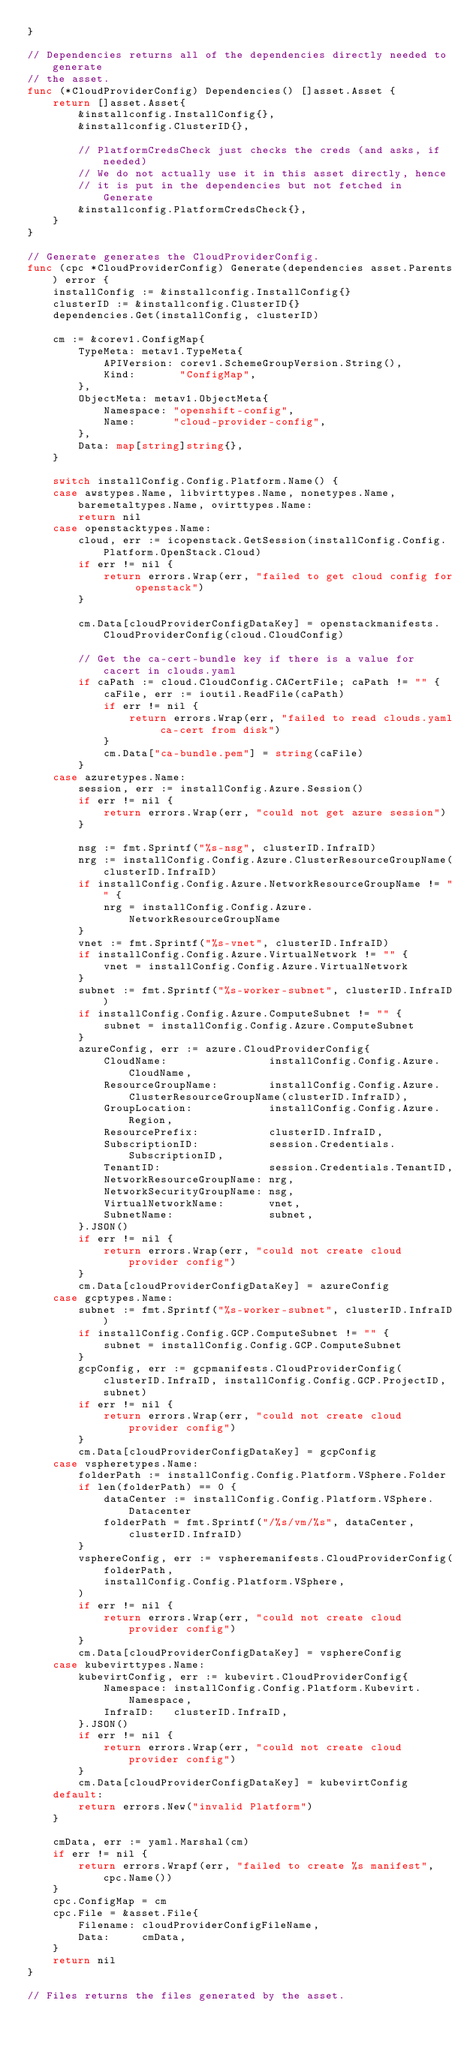<code> <loc_0><loc_0><loc_500><loc_500><_Go_>}

// Dependencies returns all of the dependencies directly needed to generate
// the asset.
func (*CloudProviderConfig) Dependencies() []asset.Asset {
	return []asset.Asset{
		&installconfig.InstallConfig{},
		&installconfig.ClusterID{},

		// PlatformCredsCheck just checks the creds (and asks, if needed)
		// We do not actually use it in this asset directly, hence
		// it is put in the dependencies but not fetched in Generate
		&installconfig.PlatformCredsCheck{},
	}
}

// Generate generates the CloudProviderConfig.
func (cpc *CloudProviderConfig) Generate(dependencies asset.Parents) error {
	installConfig := &installconfig.InstallConfig{}
	clusterID := &installconfig.ClusterID{}
	dependencies.Get(installConfig, clusterID)

	cm := &corev1.ConfigMap{
		TypeMeta: metav1.TypeMeta{
			APIVersion: corev1.SchemeGroupVersion.String(),
			Kind:       "ConfigMap",
		},
		ObjectMeta: metav1.ObjectMeta{
			Namespace: "openshift-config",
			Name:      "cloud-provider-config",
		},
		Data: map[string]string{},
	}

	switch installConfig.Config.Platform.Name() {
	case awstypes.Name, libvirttypes.Name, nonetypes.Name, baremetaltypes.Name, ovirttypes.Name:
		return nil
	case openstacktypes.Name:
		cloud, err := icopenstack.GetSession(installConfig.Config.Platform.OpenStack.Cloud)
		if err != nil {
			return errors.Wrap(err, "failed to get cloud config for openstack")
		}

		cm.Data[cloudProviderConfigDataKey] = openstackmanifests.CloudProviderConfig(cloud.CloudConfig)

		// Get the ca-cert-bundle key if there is a value for cacert in clouds.yaml
		if caPath := cloud.CloudConfig.CACertFile; caPath != "" {
			caFile, err := ioutil.ReadFile(caPath)
			if err != nil {
				return errors.Wrap(err, "failed to read clouds.yaml ca-cert from disk")
			}
			cm.Data["ca-bundle.pem"] = string(caFile)
		}
	case azuretypes.Name:
		session, err := installConfig.Azure.Session()
		if err != nil {
			return errors.Wrap(err, "could not get azure session")
		}

		nsg := fmt.Sprintf("%s-nsg", clusterID.InfraID)
		nrg := installConfig.Config.Azure.ClusterResourceGroupName(clusterID.InfraID)
		if installConfig.Config.Azure.NetworkResourceGroupName != "" {
			nrg = installConfig.Config.Azure.NetworkResourceGroupName
		}
		vnet := fmt.Sprintf("%s-vnet", clusterID.InfraID)
		if installConfig.Config.Azure.VirtualNetwork != "" {
			vnet = installConfig.Config.Azure.VirtualNetwork
		}
		subnet := fmt.Sprintf("%s-worker-subnet", clusterID.InfraID)
		if installConfig.Config.Azure.ComputeSubnet != "" {
			subnet = installConfig.Config.Azure.ComputeSubnet
		}
		azureConfig, err := azure.CloudProviderConfig{
			CloudName:                installConfig.Config.Azure.CloudName,
			ResourceGroupName:        installConfig.Config.Azure.ClusterResourceGroupName(clusterID.InfraID),
			GroupLocation:            installConfig.Config.Azure.Region,
			ResourcePrefix:           clusterID.InfraID,
			SubscriptionID:           session.Credentials.SubscriptionID,
			TenantID:                 session.Credentials.TenantID,
			NetworkResourceGroupName: nrg,
			NetworkSecurityGroupName: nsg,
			VirtualNetworkName:       vnet,
			SubnetName:               subnet,
		}.JSON()
		if err != nil {
			return errors.Wrap(err, "could not create cloud provider config")
		}
		cm.Data[cloudProviderConfigDataKey] = azureConfig
	case gcptypes.Name:
		subnet := fmt.Sprintf("%s-worker-subnet", clusterID.InfraID)
		if installConfig.Config.GCP.ComputeSubnet != "" {
			subnet = installConfig.Config.GCP.ComputeSubnet
		}
		gcpConfig, err := gcpmanifests.CloudProviderConfig(clusterID.InfraID, installConfig.Config.GCP.ProjectID, subnet)
		if err != nil {
			return errors.Wrap(err, "could not create cloud provider config")
		}
		cm.Data[cloudProviderConfigDataKey] = gcpConfig
	case vspheretypes.Name:
		folderPath := installConfig.Config.Platform.VSphere.Folder
		if len(folderPath) == 0 {
			dataCenter := installConfig.Config.Platform.VSphere.Datacenter
			folderPath = fmt.Sprintf("/%s/vm/%s", dataCenter, clusterID.InfraID)
		}
		vsphereConfig, err := vspheremanifests.CloudProviderConfig(
			folderPath,
			installConfig.Config.Platform.VSphere,
		)
		if err != nil {
			return errors.Wrap(err, "could not create cloud provider config")
		}
		cm.Data[cloudProviderConfigDataKey] = vsphereConfig
	case kubevirttypes.Name:
		kubevirtConfig, err := kubevirt.CloudProviderConfig{
			Namespace: installConfig.Config.Platform.Kubevirt.Namespace,
			InfraID:   clusterID.InfraID,
		}.JSON()
		if err != nil {
			return errors.Wrap(err, "could not create cloud provider config")
		}
		cm.Data[cloudProviderConfigDataKey] = kubevirtConfig
	default:
		return errors.New("invalid Platform")
	}

	cmData, err := yaml.Marshal(cm)
	if err != nil {
		return errors.Wrapf(err, "failed to create %s manifest", cpc.Name())
	}
	cpc.ConfigMap = cm
	cpc.File = &asset.File{
		Filename: cloudProviderConfigFileName,
		Data:     cmData,
	}
	return nil
}

// Files returns the files generated by the asset.</code> 